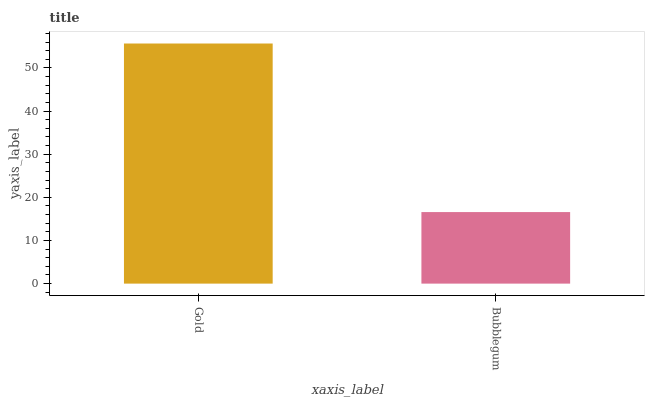Is Bubblegum the minimum?
Answer yes or no. Yes. Is Gold the maximum?
Answer yes or no. Yes. Is Bubblegum the maximum?
Answer yes or no. No. Is Gold greater than Bubblegum?
Answer yes or no. Yes. Is Bubblegum less than Gold?
Answer yes or no. Yes. Is Bubblegum greater than Gold?
Answer yes or no. No. Is Gold less than Bubblegum?
Answer yes or no. No. Is Gold the high median?
Answer yes or no. Yes. Is Bubblegum the low median?
Answer yes or no. Yes. Is Bubblegum the high median?
Answer yes or no. No. Is Gold the low median?
Answer yes or no. No. 